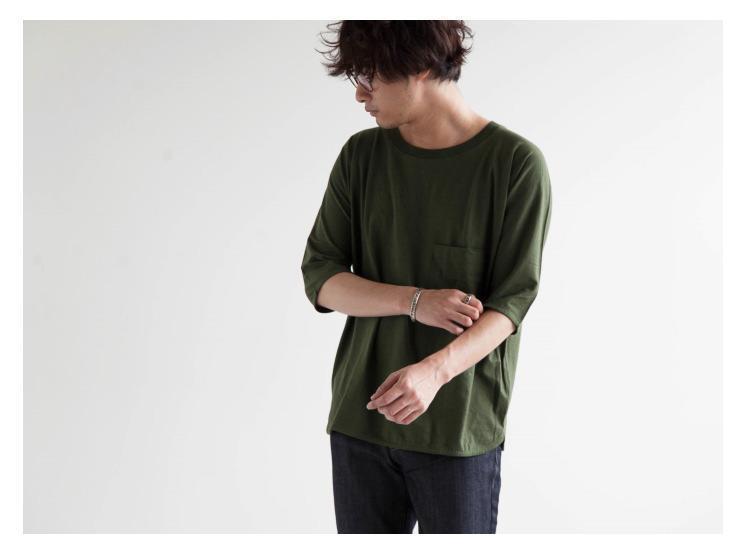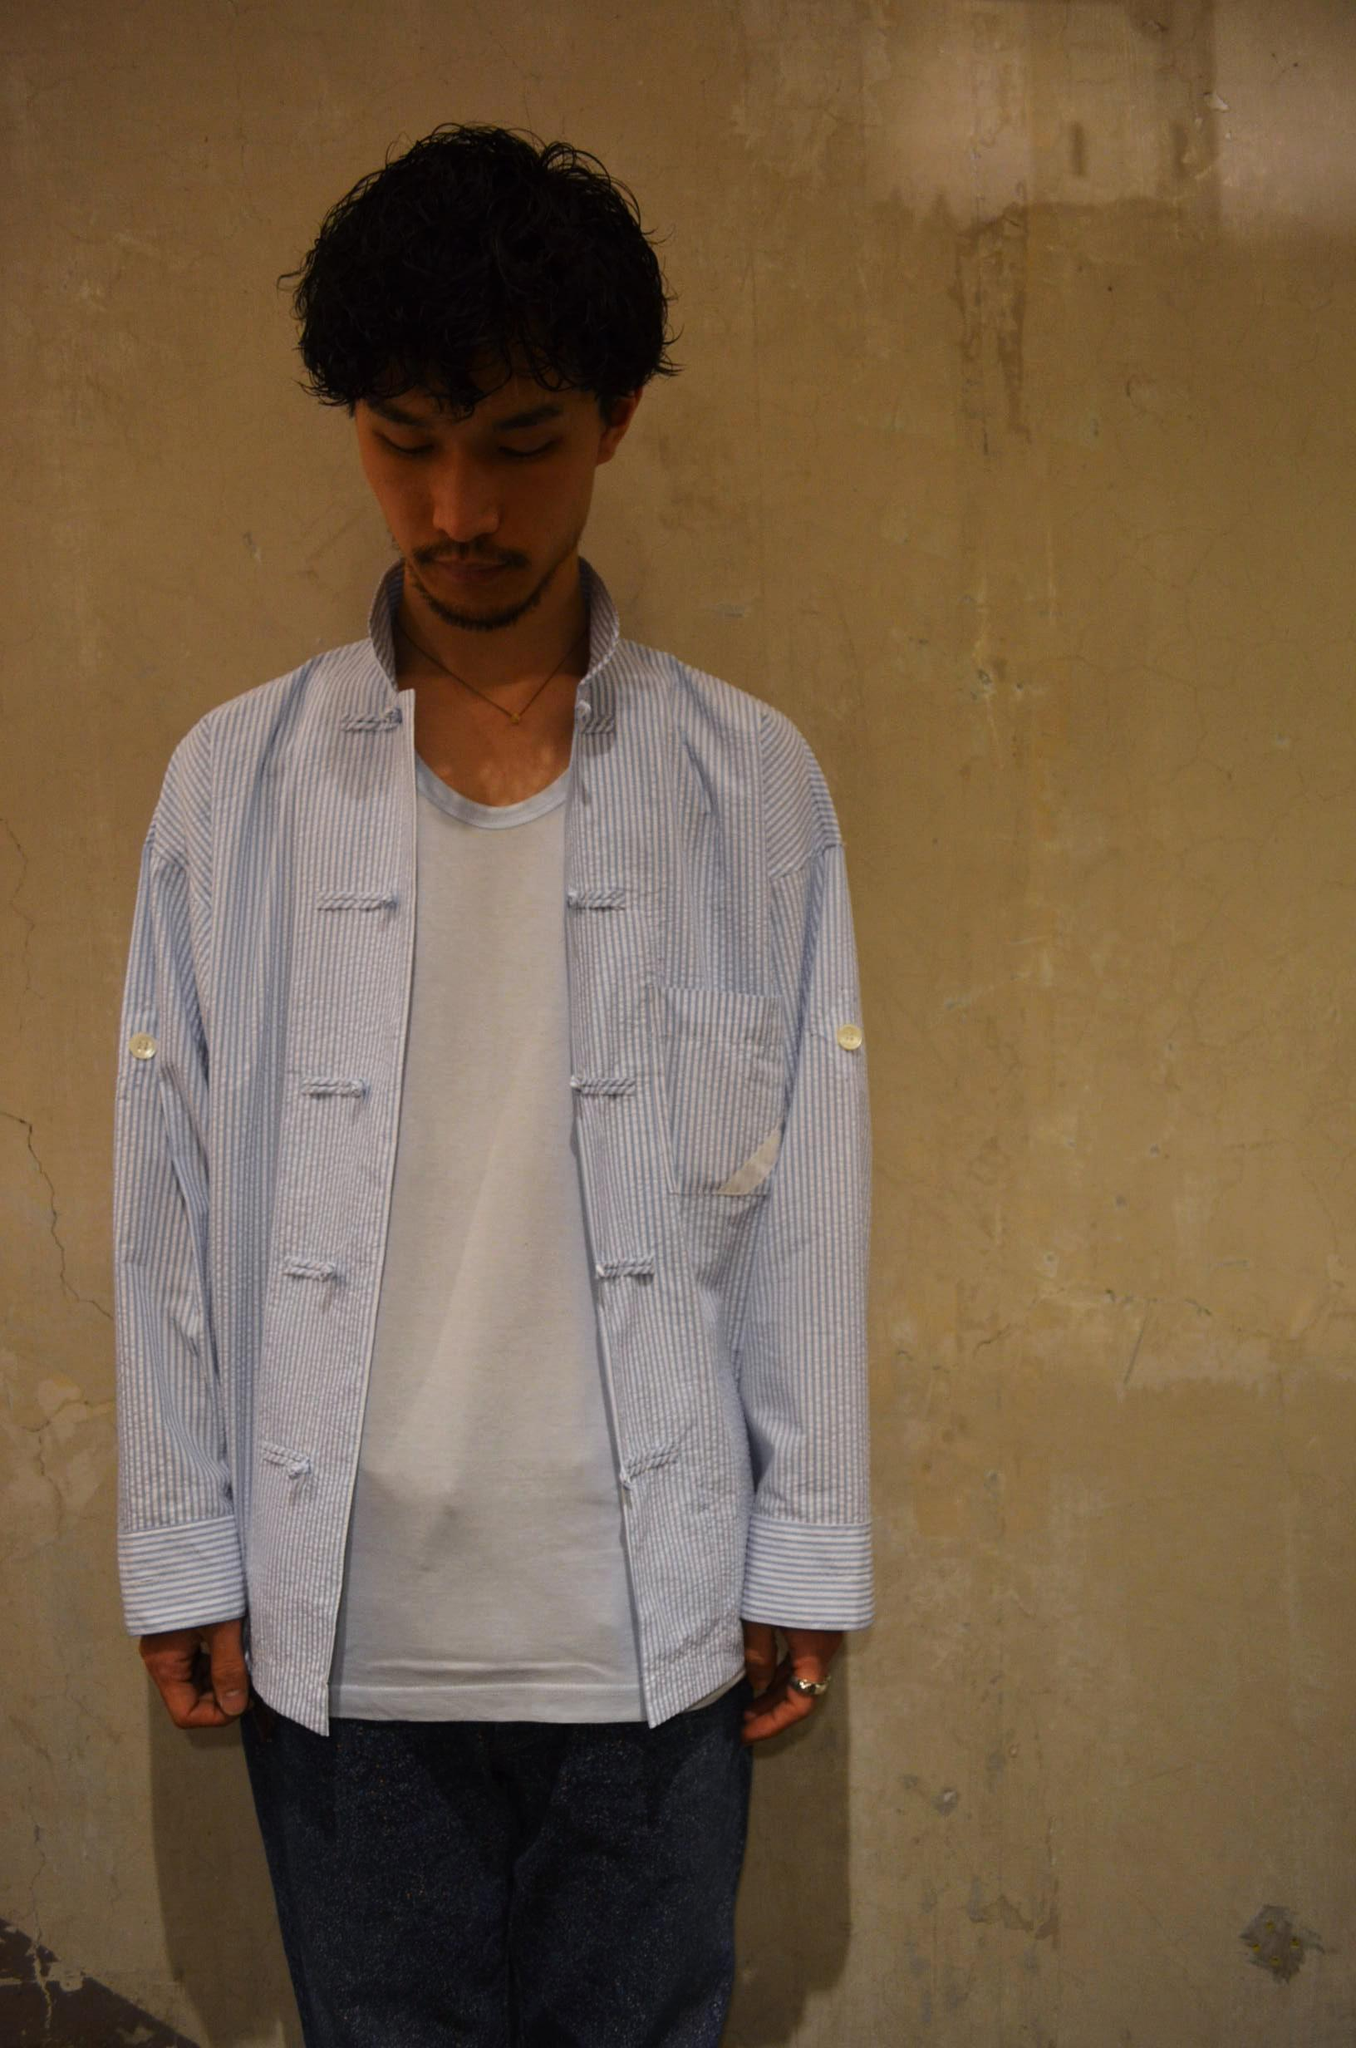The first image is the image on the left, the second image is the image on the right. For the images shown, is this caption "All shirts are white or blue, and have short sleeves." true? Answer yes or no. No. The first image is the image on the left, the second image is the image on the right. Examine the images to the left and right. Is the description "the white t-shirt in the image on the left has a breast pocket" accurate? Answer yes or no. No. 